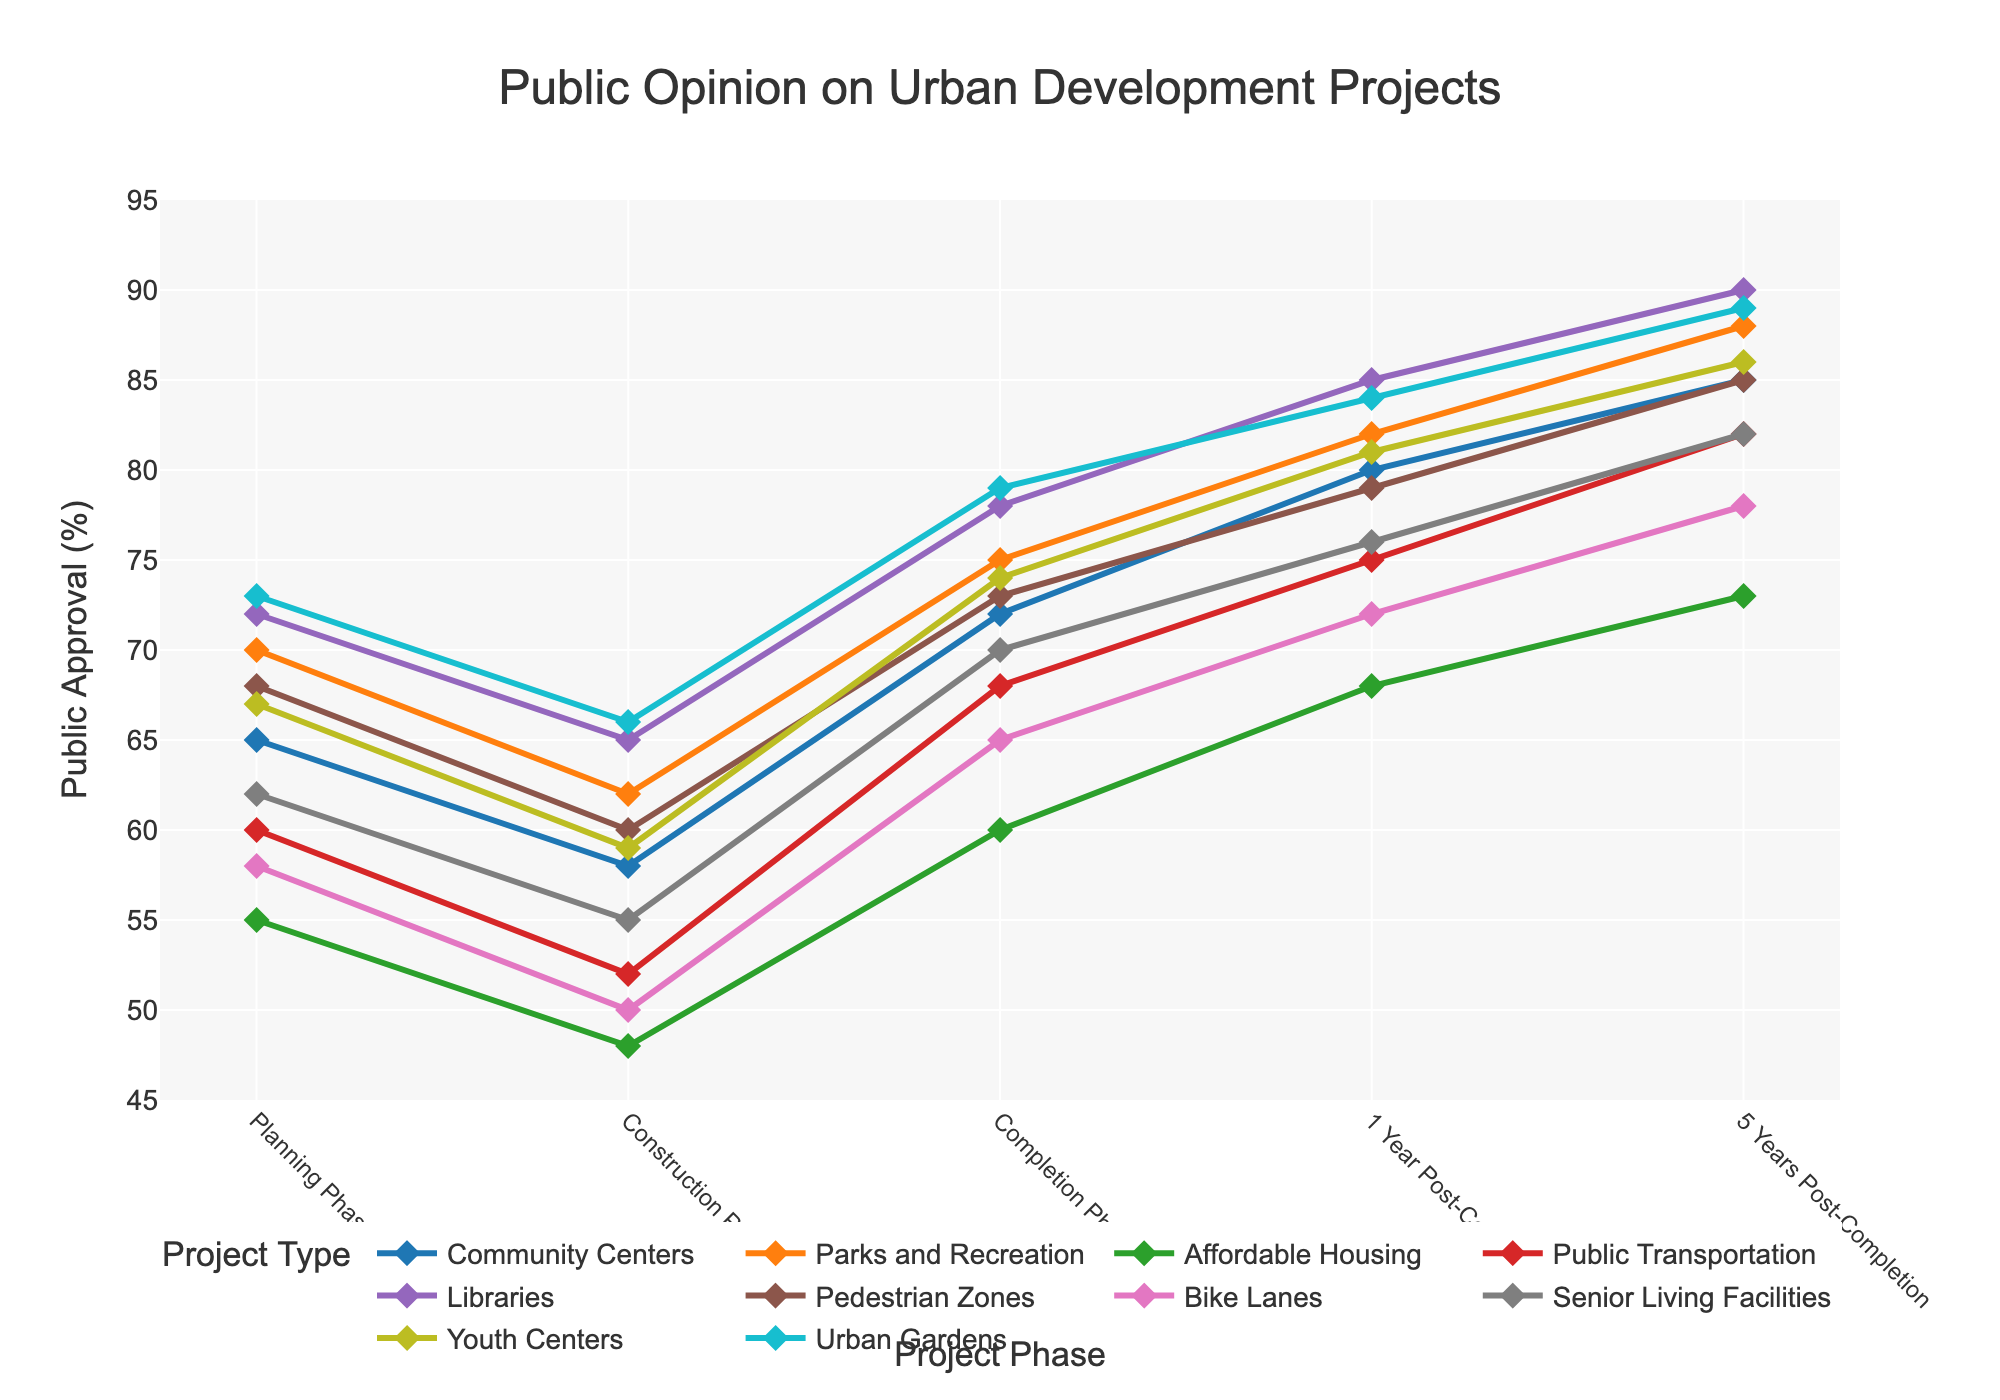What's the trend of public approval for Libraries throughout the project lifecycle? The approval for Libraries starts at 72% in the Planning Phase, then decreases to 65% in the Construction Phase. Post-construction, the approval increases to 78% at Completion Phase, and further to 85% and 90% respectively at 1 Year and 5 Years Post-Completion.
Answer: Increasing overall with a dip during Construction Phase Which project type has the lowest approval rating during the Construction Phase? By comparing the approval ratings, Affordable Housing has the lowest approval at 48% during the Construction Phase.
Answer: Affordable Housing What is the difference in public approval for Community Centers between Planning Phase and 5 Years Post-Completion? The approval for Community Centers in the Planning Phase is 65% and increases to 85% in the 5 Years Post-Completion. Thus, the difference is 85 - 65 = 20%.
Answer: 20% Which project type shows the greatest increase in public approval from Construction Phase to 1 Year Post-Completion? By calculating the increases for each project: Libraries (85-65=20), Affordable Housing (68-48=20), and Public Transportation (75-52=23). Public Transportation shows the greatest increase of 23%.
Answer: Public Transportation How does the approval rating for Urban Gardens compare to Senior Living Facilities in the Completion Phase? The approval for Urban Gardens at Completion Phase is 79%, while for Senior Living Facilities it is 70%. Urban Gardens has a higher approval rating by 9%.
Answer: Urban Gardens is higher by 9% What is the average public approval for Parks and Recreation across all phases? Adding the ratings: 70 + 62 + 75 + 82 + 88 = 377. Then, the average is 377 / 5 = 75.4%.
Answer: 75.4% Which project type reaches the highest public approval 5 Years Post-Completion? The highest approval rating 5 Years Post-Completion is for Libraries at 90%.
Answer: Libraries Which phase shows the highest average public approval across all project types? Summing up the ratings for each phase: Planning (650), Construction (575), Completion (714), 1 Year Post-Completion (792), 5 Years Post-Completion (843). Dividing by 10 project types, we get averages: Planning (65), Construction (57.5), Completion (71.4), 1 Year Post-Completion (79.2), 5 Years Post-Completion (84.3). The 5 Years Post-Completion has the highest average approval.
Answer: 5 Years Post-Completion How does the approval trend for Bike Lanes compare to that of Youth Centers from Planning Phase to Completion Phase? Approval for Bike Lanes: 58, 50, 65; Youth Centers: 67, 59, 74. Both show an initial dip and then a rise at Completion, with Youth Centers having consistently higher approval rates.
Answer: Youth Centers have higher rates but similar trend 